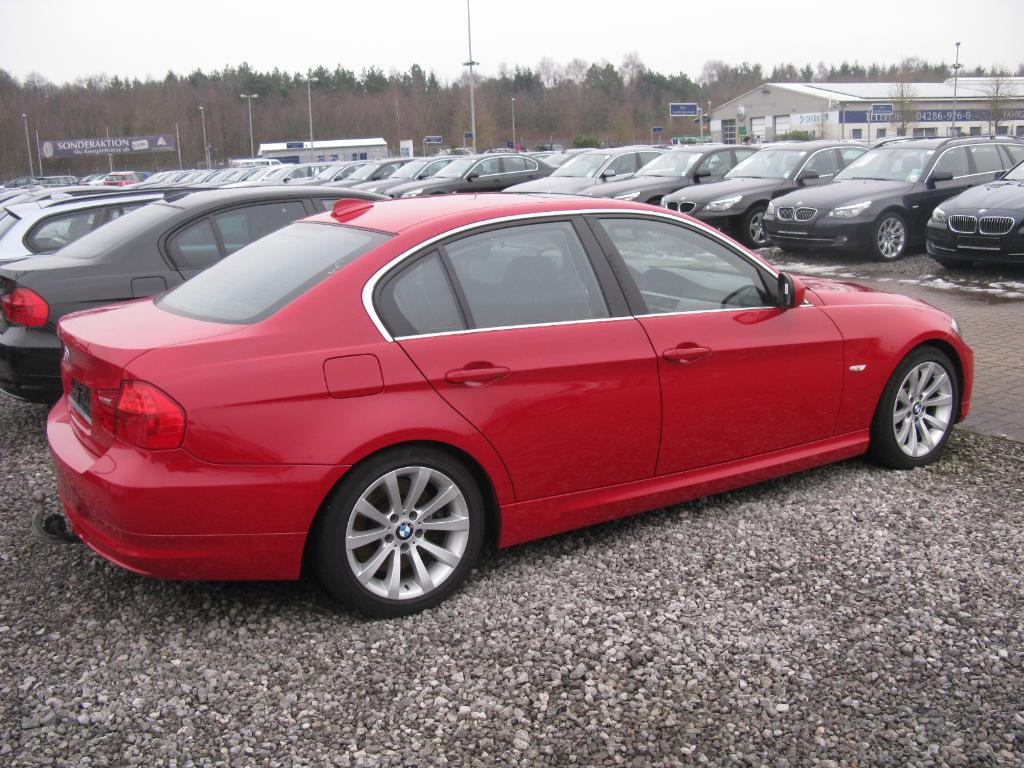What can be seen in the image that is used for transportation? There are vehicles parked in the image. What is located behind the vehicles? There are poles and boards behind the vehicles. What can be seen in the background of the image? There is a building, trees, and the sky visible in the background. How many tickets are attached to the sugar cork in the image? There is no sugar cork or tickets present in the image. 